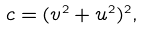Convert formula to latex. <formula><loc_0><loc_0><loc_500><loc_500>c = ( v ^ { 2 } + u ^ { 2 } ) ^ { 2 } ,</formula> 